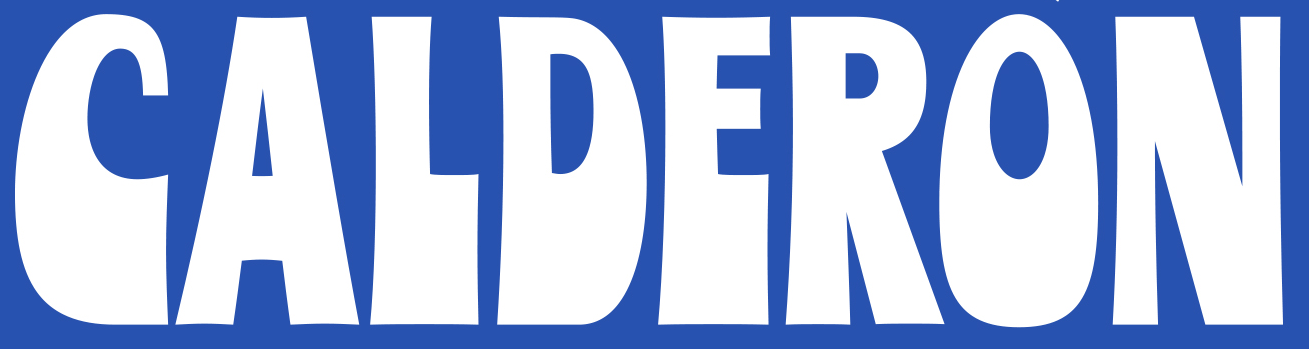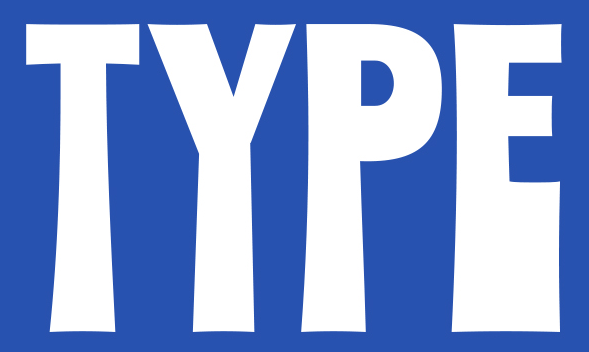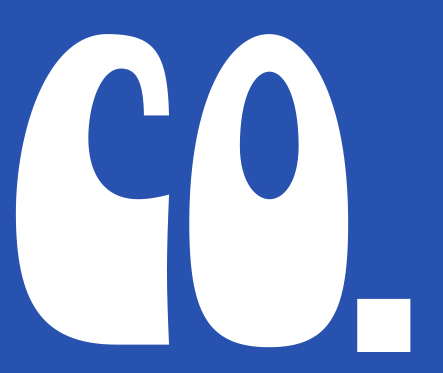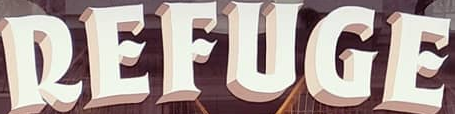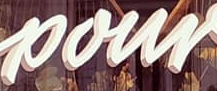What text is displayed in these images sequentially, separated by a semicolon? CALDERON; TYPE; CO.; REFUGE; pour 